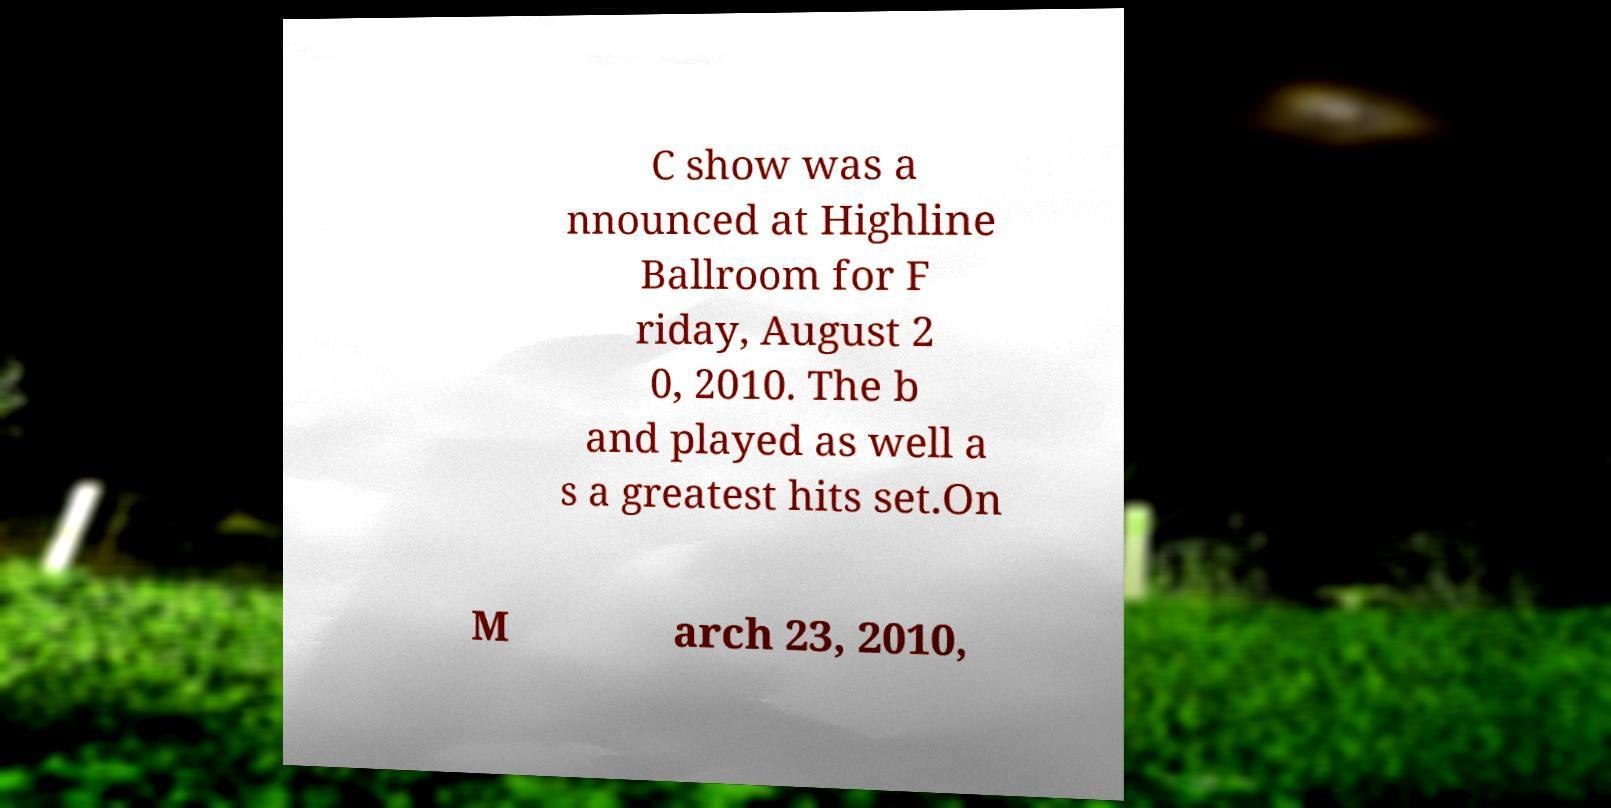Could you assist in decoding the text presented in this image and type it out clearly? C show was a nnounced at Highline Ballroom for F riday, August 2 0, 2010. The b and played as well a s a greatest hits set.On M arch 23, 2010, 